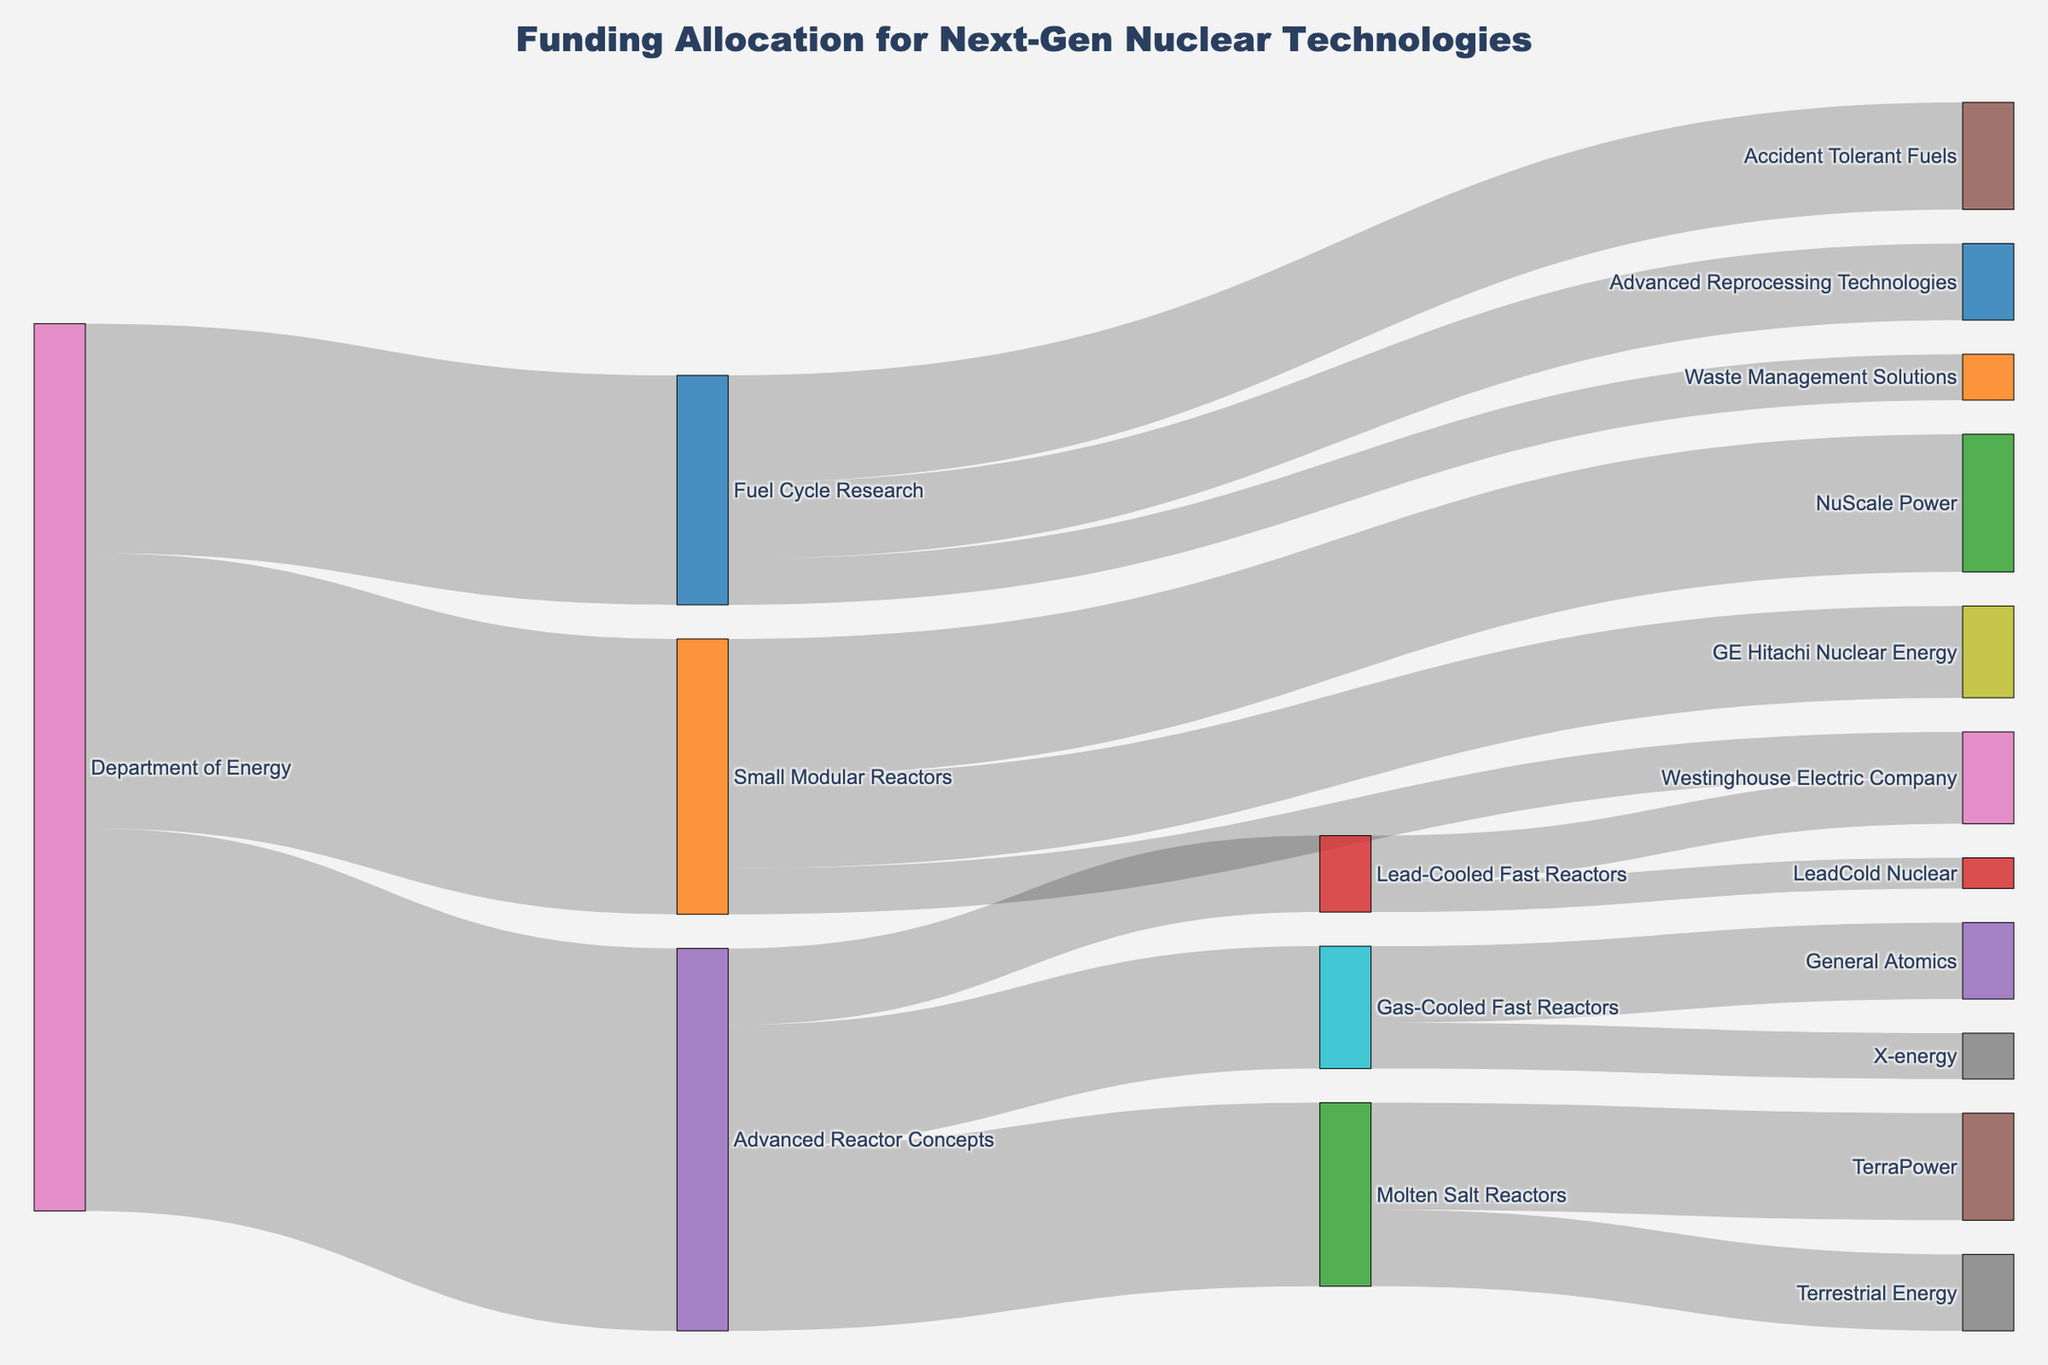How much total funding does the Department of Energy allocate to research projects? Sum up the values for each project starting from the Department of Energy: 250 (Advanced Reactor Concepts) + 180 (Small Modular Reactors) + 150 (Fuel Cycle Research). The total funding is 580.
Answer: 580 Which project under Advanced Reactor Concepts receives the most funding? Compare the funding amounts for each project under Advanced Reactor Concepts: 120 (Molten Salt Reactors), 80 (Gas-Cooled Fast Reactors), and 50 (Lead-Cooled Fast Reactors). Molten Salt Reactors receives the most funding.
Answer: Molten Salt Reactors How does the funding for NuScale Power compare to that for GE Hitachi Nuclear Energy? The funding amounts are 90 for NuScale Power and 60 for GE Hitachi Nuclear Energy. 90 is greater than 60, so NuScale Power receives more funding.
Answer: NuScale Power receives more funding What is the total funding for Small Modular Reactors? Sum the funding values for all targets under Small Modular Reactors: 90 (NuScale Power) + 60 (GE Hitachi Nuclear Energy) + 30 (Westinghouse Electric Company). The total funding is 180.
Answer: 180 Which company receives funding from both Small Modular Reactors and Lead-Cooled Fast Reactors? Identify the common target between the two funding paths: Westinghouse Electric Company receives funding from both (30 from Small Modular Reactors and 30 from Lead-Cooled Fast Reactors).
Answer: Westinghouse Electric Company Compare the funding for TerraPower and Terrestrial Energy within Molten Salt Reactors. Which one receives more funding? TerraPower receives 70 and Terrestrial Energy receives 50. Comparing both values, TerraPower receives more funding.
Answer: TerraPower How does the funding allocation for Advanced Reprocessing Technologies under Fuel Cycle Research compare to that for General Atomics under Gas-Cooled Fast Reactors? The funding amounts are 50 for Advanced Reprocessing Technologies and 50 for General Atomics. They receive equal funding.
Answer: Equal funding What is the proportion of funding allocated to Gas-Cooled Fast Reactors versus Lead-Cooled Fast Reactors within Advanced Reactor Concepts? Gas-Cooled Fast Reactors receives 80 and Lead-Cooled Fast Reactors receives 50. The proportion is 80:50 or simplified to 8:5.
Answer: 8:5 What percentage of Fuel Cycle Research's total funding is allocated to Accident Tolerant Fuels? Accident Tolerant Fuels receives 70 out of Fuel Cycle Research's total 150. The percentage is (70/150) * 100 = 46.67%.
Answer: 46.67% Which type of project receives the smallest amount of funding from the Department of Energy? Fuel Cycle Research receives 150, Small Modular Reactors receives 180, and Advanced Reactor Concepts receives 250. Fuel Cycle Research receives the smallest amount.
Answer: Fuel Cycle Research 